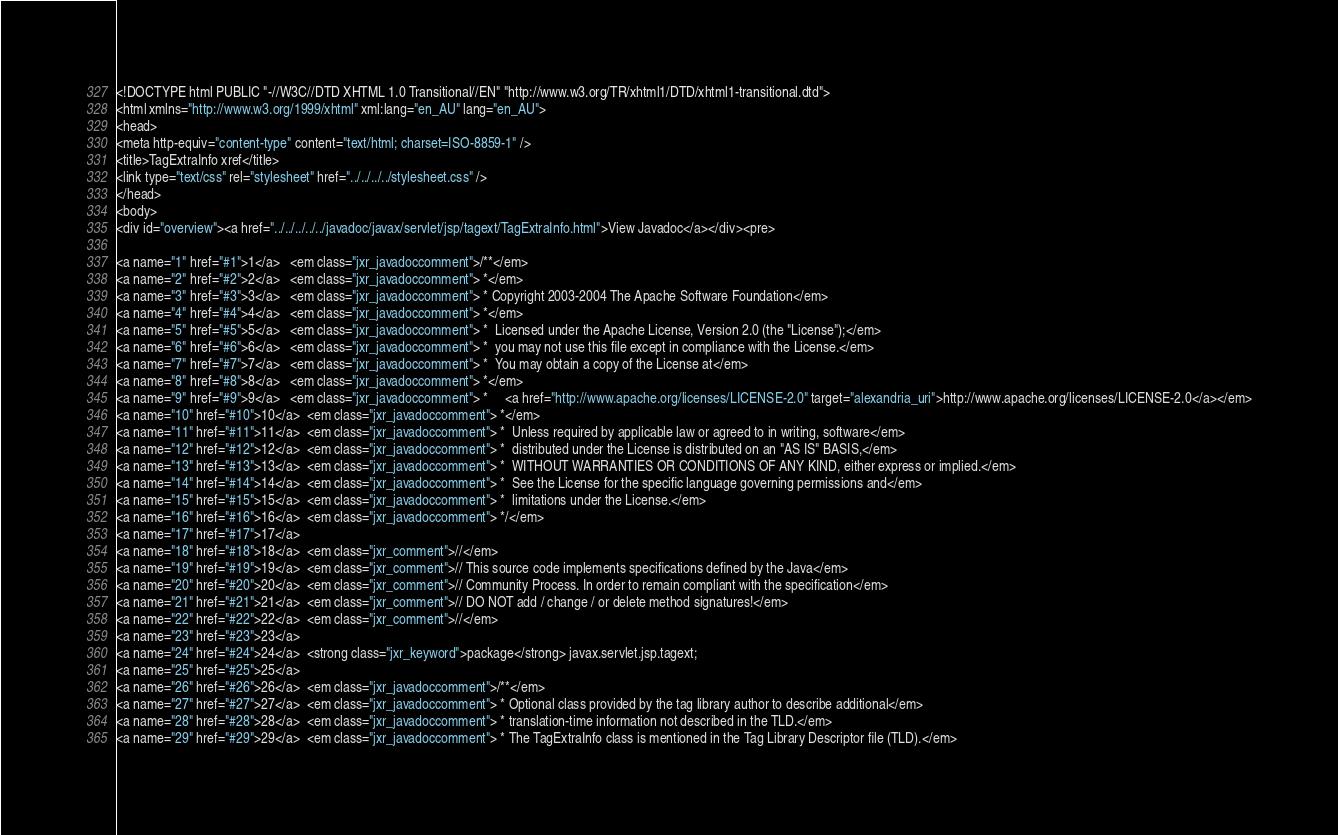Convert code to text. <code><loc_0><loc_0><loc_500><loc_500><_HTML_><!DOCTYPE html PUBLIC "-//W3C//DTD XHTML 1.0 Transitional//EN" "http://www.w3.org/TR/xhtml1/DTD/xhtml1-transitional.dtd">
<html xmlns="http://www.w3.org/1999/xhtml" xml:lang="en_AU" lang="en_AU">
<head>
<meta http-equiv="content-type" content="text/html; charset=ISO-8859-1" />
<title>TagExtraInfo xref</title>
<link type="text/css" rel="stylesheet" href="../../../../stylesheet.css" />
</head>
<body>
<div id="overview"><a href="../../../../../javadoc/javax/servlet/jsp/tagext/TagExtraInfo.html">View Javadoc</a></div><pre>

<a name="1" href="#1">1</a>   <em class="jxr_javadoccomment">/**</em>
<a name="2" href="#2">2</a>   <em class="jxr_javadoccomment"> *</em>
<a name="3" href="#3">3</a>   <em class="jxr_javadoccomment"> * Copyright 2003-2004 The Apache Software Foundation</em>
<a name="4" href="#4">4</a>   <em class="jxr_javadoccomment"> *</em>
<a name="5" href="#5">5</a>   <em class="jxr_javadoccomment"> *  Licensed under the Apache License, Version 2.0 (the "License");</em>
<a name="6" href="#6">6</a>   <em class="jxr_javadoccomment"> *  you may not use this file except in compliance with the License.</em>
<a name="7" href="#7">7</a>   <em class="jxr_javadoccomment"> *  You may obtain a copy of the License at</em>
<a name="8" href="#8">8</a>   <em class="jxr_javadoccomment"> *</em>
<a name="9" href="#9">9</a>   <em class="jxr_javadoccomment"> *     <a href="http://www.apache.org/licenses/LICENSE-2.0" target="alexandria_uri">http://www.apache.org/licenses/LICENSE-2.0</a></em>
<a name="10" href="#10">10</a>  <em class="jxr_javadoccomment"> *</em>
<a name="11" href="#11">11</a>  <em class="jxr_javadoccomment"> *  Unless required by applicable law or agreed to in writing, software</em>
<a name="12" href="#12">12</a>  <em class="jxr_javadoccomment"> *  distributed under the License is distributed on an "AS IS" BASIS,</em>
<a name="13" href="#13">13</a>  <em class="jxr_javadoccomment"> *  WITHOUT WARRANTIES OR CONDITIONS OF ANY KIND, either express or implied.</em>
<a name="14" href="#14">14</a>  <em class="jxr_javadoccomment"> *  See the License for the specific language governing permissions and</em>
<a name="15" href="#15">15</a>  <em class="jxr_javadoccomment"> *  limitations under the License.</em>
<a name="16" href="#16">16</a>  <em class="jxr_javadoccomment"> */</em>
<a name="17" href="#17">17</a>  
<a name="18" href="#18">18</a>  <em class="jxr_comment">//</em>
<a name="19" href="#19">19</a>  <em class="jxr_comment">// This source code implements specifications defined by the Java</em>
<a name="20" href="#20">20</a>  <em class="jxr_comment">// Community Process. In order to remain compliant with the specification</em>
<a name="21" href="#21">21</a>  <em class="jxr_comment">// DO NOT add / change / or delete method signatures!</em>
<a name="22" href="#22">22</a>  <em class="jxr_comment">//</em>
<a name="23" href="#23">23</a>  
<a name="24" href="#24">24</a>  <strong class="jxr_keyword">package</strong> javax.servlet.jsp.tagext;
<a name="25" href="#25">25</a>  
<a name="26" href="#26">26</a>  <em class="jxr_javadoccomment">/**</em>
<a name="27" href="#27">27</a>  <em class="jxr_javadoccomment"> * Optional class provided by the tag library author to describe additional</em>
<a name="28" href="#28">28</a>  <em class="jxr_javadoccomment"> * translation-time information not described in the TLD.</em>
<a name="29" href="#29">29</a>  <em class="jxr_javadoccomment"> * The TagExtraInfo class is mentioned in the Tag Library Descriptor file (TLD).</em></code> 